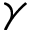Convert formula to latex. <formula><loc_0><loc_0><loc_500><loc_500>\gamma</formula> 